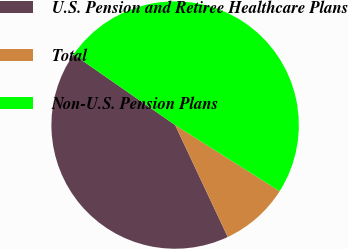Convert chart. <chart><loc_0><loc_0><loc_500><loc_500><pie_chart><fcel>U.S. Pension and Retiree Healthcare Plans<fcel>Total<fcel>Non-U.S. Pension Plans<nl><fcel>41.66%<fcel>9.02%<fcel>49.32%<nl></chart> 